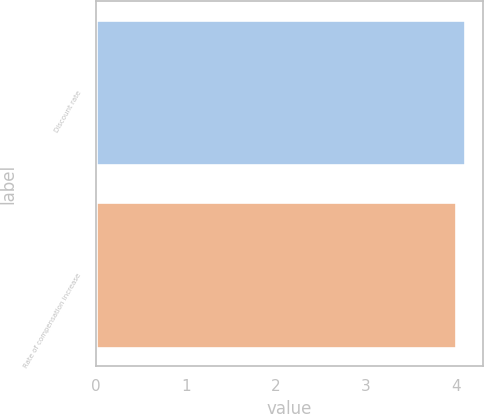Convert chart. <chart><loc_0><loc_0><loc_500><loc_500><bar_chart><fcel>Discount rate<fcel>Rate of compensation increase<nl><fcel>4.1<fcel>4<nl></chart> 